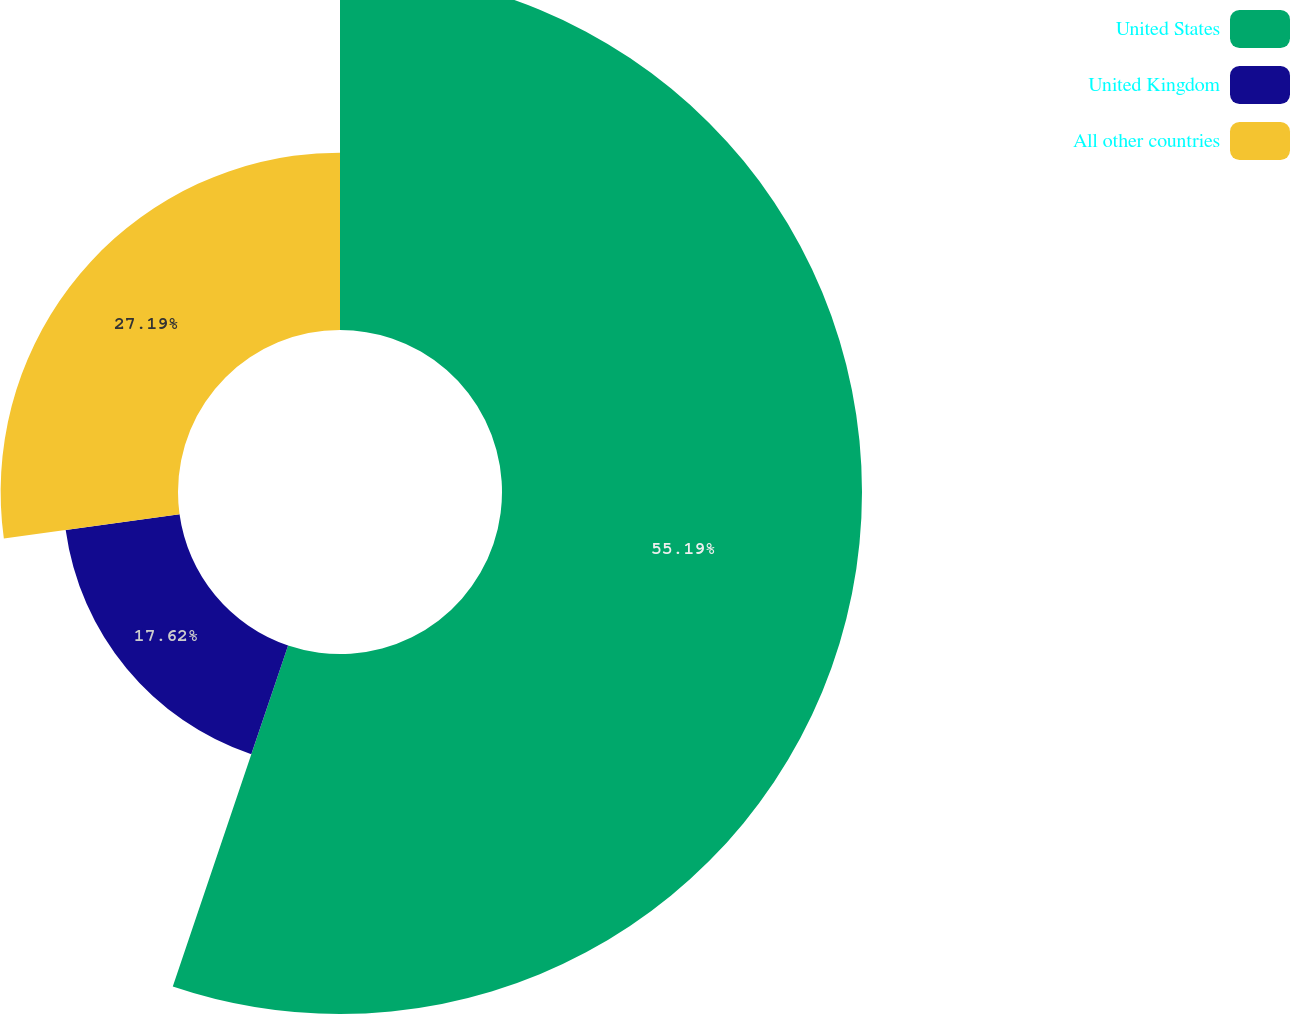Convert chart. <chart><loc_0><loc_0><loc_500><loc_500><pie_chart><fcel>United States<fcel>United Kingdom<fcel>All other countries<nl><fcel>55.19%<fcel>17.62%<fcel>27.19%<nl></chart> 